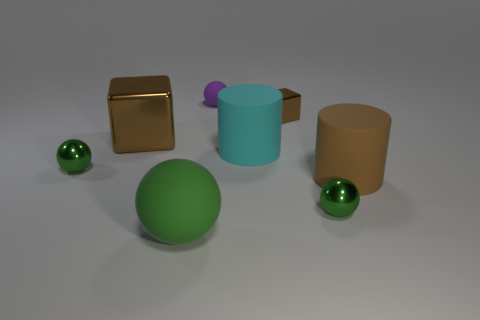What number of tiny spheres have the same color as the big matte sphere?
Your answer should be compact. 2. What is the material of the cylinder that is the same color as the big shiny cube?
Offer a terse response. Rubber. There is a large rubber ball; is it the same color as the small shiny sphere that is behind the large brown matte object?
Offer a terse response. Yes. There is another matte thing that is the same shape as the big cyan object; what is its size?
Your response must be concise. Large. Are the cyan cylinder and the brown block on the right side of the big cyan cylinder made of the same material?
Offer a terse response. No. How many things are either small purple things or cyan matte cylinders?
Keep it short and to the point. 2. Does the matte sphere right of the green rubber thing have the same size as the metal cube to the right of the large brown metallic thing?
Your answer should be compact. Yes. What number of blocks are either brown objects or big objects?
Give a very brief answer. 2. Is there a small brown shiny thing?
Your answer should be very brief. Yes. Are there any other things that have the same shape as the green matte thing?
Your response must be concise. Yes. 